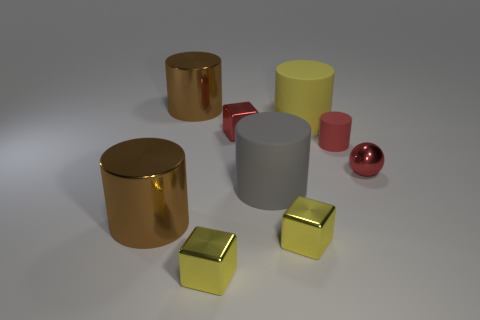What shape is the small shiny thing that is the same color as the small ball?
Give a very brief answer. Cube. How many yellow blocks are on the left side of the big metallic cylinder to the right of the large brown shiny object in front of the red block?
Give a very brief answer. 0. How big is the brown object behind the small rubber cylinder behind the small sphere?
Provide a short and direct response. Large. The red thing that is made of the same material as the gray object is what size?
Provide a short and direct response. Small. The tiny thing that is behind the shiny sphere and to the right of the yellow matte cylinder has what shape?
Give a very brief answer. Cylinder. Are there the same number of red blocks that are behind the small red matte cylinder and red shiny blocks?
Make the answer very short. Yes. What number of things are either big brown cylinders or small cubes in front of the sphere?
Your answer should be compact. 4. Is there a large matte thing of the same shape as the small red rubber object?
Keep it short and to the point. Yes. Are there the same number of yellow cylinders that are right of the yellow rubber cylinder and red matte cylinders that are left of the red metal cube?
Make the answer very short. Yes. Are there any other things that have the same size as the yellow rubber cylinder?
Provide a succinct answer. Yes. 